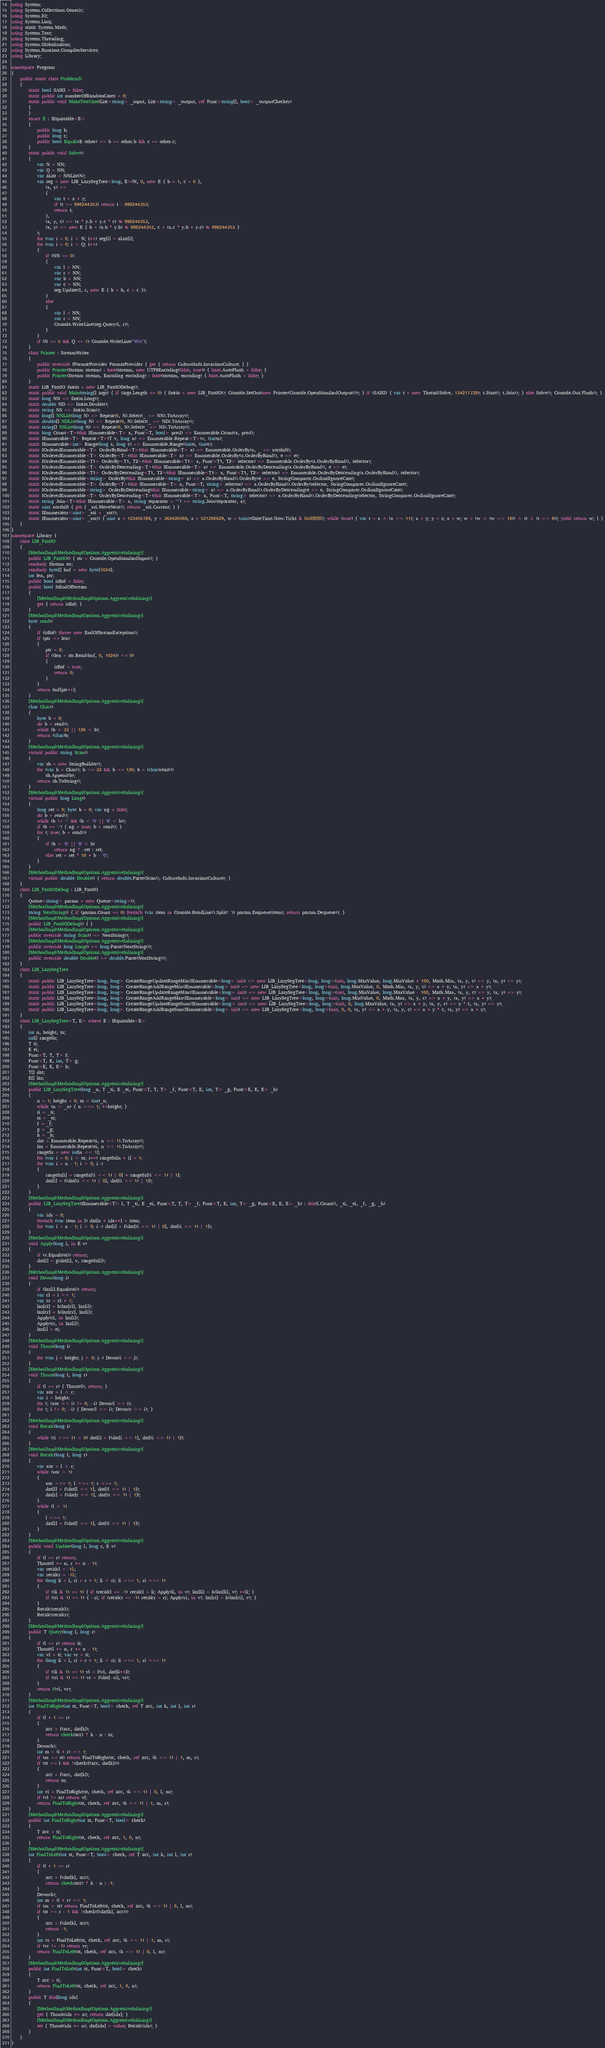Convert code to text. <code><loc_0><loc_0><loc_500><loc_500><_C#_>using System;
using System.Collections.Generic;
using System.IO;
using System.Linq;
using static System.Math;
using System.Text;
using System.Threading;
using System.Globalization;
using System.Runtime.CompilerServices;
using Library;

namespace Program
{
    public static class ProblemD
    {
        static bool SAIKI = false;
        static public int numberOfRandomCases = 0;
        static public void MakeTestCase(List<string> _input, List<string> _output, ref Func<string[], bool> _outputChecker)
        {
        }
        struct E : IEquatable<E>
        {
            public long b;
            public long c;
            public bool Equals(E other) => b == other.b && c == other.c;
        }
        static public void Solve()
        {
            var N = NN;
            var Q = NN;
            var aList = NNList(N);
            var seg = new LIB_LazySegTree<long, E>(N, 0, new E { b = 1, c = 0 },
                (x, y) =>
                {
                    var t = x + y;
                    if (t >= 998244353) return t - 998244353;
                    return t;
                },
                (x, y, c) => (x * y.b + y.c * c) % 998244353,
                (x, y) => new E { b = (x.b * y.b) % 998244353, c = (x.c * y.b + y.c) % 998244353 }
            );
            for (var i = 0; i < N; i++) seg[i] = aList[i];
            for (var i = 0; i < Q; i++)
            {
                if (NN == 0)
                {
                    var l = NN;
                    var r = NN;
                    var b = NN;
                    var c = NN;
                    seg.Update(l, r, new E { b = b, c = c });
                }
                else
                {
                    var l = NN;
                    var r = NN;
                    Console.WriteLine(seg.Query(l, r));
                }
            }
            if (N == 5 && Q == 7) Console.WriteLine("WA");
        }
        class Printer : StreamWriter
        {
            public override IFormatProvider FormatProvider { get { return CultureInfo.InvariantCulture; } }
            public Printer(Stream stream) : base(stream, new UTF8Encoding(false, true)) { base.AutoFlush = false; }
            public Printer(Stream stream, Encoding encoding) : base(stream, encoding) { base.AutoFlush = false; }
        }
        static LIB_FastIO fastio = new LIB_FastIODebug();
        static public void Main(string[] args) { if (args.Length == 0) { fastio = new LIB_FastIO(); Console.SetOut(new Printer(Console.OpenStandardOutput())); } if (SAIKI) { var t = new Thread(Solve, 134217728); t.Start(); t.Join(); } else Solve(); Console.Out.Flush(); }
        static long NN => fastio.Long();
        static double ND => fastio.Double();
        static string NS => fastio.Scan();
        static long[] NNList(long N) => Repeat(0, N).Select(_ => NN).ToArray();
        static double[] NDList(long N) => Repeat(0, N).Select(_ => ND).ToArray();
        static string[] NSList(long N) => Repeat(0, N).Select(_ => NS).ToArray();
        static long Count<T>(this IEnumerable<T> x, Func<T, bool> pred) => Enumerable.Count(x, pred);
        static IEnumerable<T> Repeat<T>(T v, long n) => Enumerable.Repeat<T>(v, (int)n);
        static IEnumerable<int> Range(long s, long c) => Enumerable.Range((int)s, (int)c);
        static IOrderedEnumerable<T> OrderByRand<T>(this IEnumerable<T> x) => Enumerable.OrderBy(x, _ => xorshift);
        static IOrderedEnumerable<T> OrderBy<T>(this IEnumerable<T> x) => Enumerable.OrderBy(x.OrderByRand(), e => e);
        static IOrderedEnumerable<T1> OrderBy<T1, T2>(this IEnumerable<T1> x, Func<T1, T2> selector) => Enumerable.OrderBy(x.OrderByRand(), selector);
        static IOrderedEnumerable<T> OrderByDescending<T>(this IEnumerable<T> x) => Enumerable.OrderByDescending(x.OrderByRand(), e => e);
        static IOrderedEnumerable<T1> OrderByDescending<T1, T2>(this IEnumerable<T1> x, Func<T1, T2> selector) => Enumerable.OrderByDescending(x.OrderByRand(), selector);
        static IOrderedEnumerable<string> OrderBy(this IEnumerable<string> x) => x.OrderByRand().OrderBy(e => e, StringComparer.OrdinalIgnoreCase);
        static IOrderedEnumerable<T> OrderBy<T>(this IEnumerable<T> x, Func<T, string> selector) => x.OrderByRand().OrderBy(selector, StringComparer.OrdinalIgnoreCase);
        static IOrderedEnumerable<string> OrderByDescending(this IEnumerable<string> x) => x.OrderByRand().OrderByDescending(e => e, StringComparer.OrdinalIgnoreCase);
        static IOrderedEnumerable<T> OrderByDescending<T>(this IEnumerable<T> x, Func<T, string> selector) => x.OrderByRand().OrderByDescending(selector, StringComparer.OrdinalIgnoreCase);
        static string Join<T>(this IEnumerable<T> x, string separator = "") => string.Join(separator, x);
        static uint xorshift { get { _xsi.MoveNext(); return _xsi.Current; } }
        static IEnumerator<uint> _xsi = _xsc();
        static IEnumerator<uint> _xsc() { uint x = 123456789, y = 362436069, z = 521288629, w = (uint)(DateTime.Now.Ticks & 0xffffffff); while (true) { var t = x ^ (x << 11); x = y; y = z; z = w; w = (w ^ (w >> 19)) ^ (t ^ (t >> 8)); yield return w; } }
    }
}
namespace Library {
    class LIB_FastIO
    {
        [MethodImpl(MethodImplOptions.AggressiveInlining)]
        public LIB_FastIO() { str = Console.OpenStandardInput(); }
        readonly Stream str;
        readonly byte[] buf = new byte[1024];
        int len, ptr;
        public bool isEof = false;
        public bool IsEndOfStream
        {
            [MethodImpl(MethodImplOptions.AggressiveInlining)]
            get { return isEof; }
        }
        [MethodImpl(MethodImplOptions.AggressiveInlining)]
        byte read()
        {
            if (isEof) throw new EndOfStreamException();
            if (ptr >= len)
            {
                ptr = 0;
                if ((len = str.Read(buf, 0, 1024)) <= 0)
                {
                    isEof = true;
                    return 0;
                }
            }
            return buf[ptr++];
        }
        [MethodImpl(MethodImplOptions.AggressiveInlining)]
        char Char()
        {
            byte b = 0;
            do b = read();
            while (b < 33 || 126 < b);
            return (char)b;
        }
        [MethodImpl(MethodImplOptions.AggressiveInlining)]
        virtual public string Scan()
        {
            var sb = new StringBuilder();
            for (var b = Char(); b >= 33 && b <= 126; b = (char)read())
                sb.Append(b);
            return sb.ToString();
        }
        [MethodImpl(MethodImplOptions.AggressiveInlining)]
        virtual public long Long()
        {
            long ret = 0; byte b = 0; var ng = false;
            do b = read();
            while (b != '-' && (b < '0' || '9' < b));
            if (b == '-') { ng = true; b = read(); }
            for (; true; b = read())
            {
                if (b < '0' || '9' < b)
                    return ng ? -ret : ret;
                else ret = ret * 10 + b - '0';
            }
        }
        [MethodImpl(MethodImplOptions.AggressiveInlining)]
        virtual public double Double() { return double.Parse(Scan(), CultureInfo.InvariantCulture); }
    }
    class LIB_FastIODebug : LIB_FastIO
    {
        Queue<string> param = new Queue<string>();
        [MethodImpl(MethodImplOptions.AggressiveInlining)]
        string NextString() { if (param.Count == 0) foreach (var item in Console.ReadLine().Split(' ')) param.Enqueue(item); return param.Dequeue(); }
        [MethodImpl(MethodImplOptions.AggressiveInlining)]
        public LIB_FastIODebug() { }
        [MethodImpl(MethodImplOptions.AggressiveInlining)]
        public override string Scan() => NextString();
        [MethodImpl(MethodImplOptions.AggressiveInlining)]
        public override long Long() => long.Parse(NextString());
        [MethodImpl(MethodImplOptions.AggressiveInlining)]
        public override double Double() => double.Parse(NextString());
    }
    class LIB_LazySegTree
    {
        static public LIB_LazySegTree<long, long> CreateRangeUpdateRangeMin(IEnumerable<long> init) => new LIB_LazySegTree<long, long>(init, long.MaxValue, long.MinValue + 100, Math.Min, (x, y, c) => y, (x, y) => y);
        static public LIB_LazySegTree<long, long> CreateRangeAddRangeMin(IEnumerable<long> init) => new LIB_LazySegTree<long, long>(init, long.MaxValue, 0, Math.Min, (x, y, c) => x + y, (x, y) => x + y);
        static public LIB_LazySegTree<long, long> CreateRangeUpdateRangeMax(IEnumerable<long> init) => new LIB_LazySegTree<long, long>(init, long.MinValue, long.MaxValue - 100, Math.Max, (x, y, c) => y, (x, y) => y);
        static public LIB_LazySegTree<long, long> CreateRangeAddRangeMax(IEnumerable<long> init) => new LIB_LazySegTree<long, long>(init, long.MinValue, 0, Math.Max, (x, y, c) => x + y, (x, y) => x + y);
        static public LIB_LazySegTree<long, long> CreateRangeUpdateRangeSum(IEnumerable<long> init) => new LIB_LazySegTree<long, long>(init, 0, long.MaxValue, (x, y) => x + y, (x, y, c) => y * c, (x, y) => y);
        static public LIB_LazySegTree<long, long> CreateRangeAddRangeSum(IEnumerable<long> init) => new LIB_LazySegTree<long, long>(init, 0, 0, (x, y) => x + y, (x, y, c) => x + y * c, (x, y) => x + y);
    }
    class LIB_LazySegTree<T, E> where E : IEquatable<E>
    {
        int n, height, sz;
        int[] rangeSz;
        T ti;
        E ei;
        Func<T, T, T> f;
        Func<T, E, int, T> g;
        Func<E, E, E> h;
        T[] dat;
        E[] laz;
        [MethodImpl(MethodImplOptions.AggressiveInlining)]
        public LIB_LazySegTree(long _n, T _ti, E _ei, Func<T, T, T> _f, Func<T, E, int, T> _g, Func<E, E, E> _h)
        {
            n = 1; height = 0; sz = (int)_n;
            while (n < _n) { n <<= 1; ++height; }
            ti = _ti;
            ei = _ei;
            f = _f;
            g = _g;
            h = _h;
            dat = Enumerable.Repeat(ti, n << 1).ToArray();
            laz = Enumerable.Repeat(ei, n << 1).ToArray();
            rangeSz = new int[n << 1];
            for (var i = 0; i < sz; i++) rangeSz[n + i] = 1;
            for (var i = n - 1; i > 0; i--)
            {
                rangeSz[i] = rangeSz[(i << 1) | 0] + rangeSz[(i << 1) | 1];
                dat[i] = f(dat[(i << 1) | 0], dat[(i << 1) | 1]);
            }
        }
        [MethodImpl(MethodImplOptions.AggressiveInlining)]
        public LIB_LazySegTree(IEnumerable<T> l, T _ti, E _ei, Func<T, T, T> _f, Func<T, E, int, T> _g, Func<E, E, E> _h) : this(l.Count(), _ti, _ei, _f, _g, _h)
        {
            var idx = 0;
            foreach (var item in l) dat[n + idx++] = item;
            for (var i = n - 1; i > 0; i--) dat[i] = f(dat[(i << 1) | 0], dat[(i << 1) | 1]);
        }
        [MethodImpl(MethodImplOptions.AggressiveInlining)]
        void Apply(long i, in E v)
        {
            if (v.Equals(ei)) return;
            dat[i] = g(dat[i], v, rangeSz[i]);
        }
        [MethodImpl(MethodImplOptions.AggressiveInlining)]
        void Down(long i)
        {
            if (laz[i].Equals(ei)) return;
            var cl = i << 1;
            var cr = cl + 1;
            laz[cl] = h(laz[cl], laz[i]);
            laz[cr] = h(laz[cr], laz[i]);
            Apply(cl, in laz[i]);
            Apply(cr, in laz[i]);
            laz[i] = ei;
        }
        [MethodImpl(MethodImplOptions.AggressiveInlining)]
        void Thrust(long i)
        {
            for (var j = height; j > 0; j--) Down(i >> j);
        }
        [MethodImpl(MethodImplOptions.AggressiveInlining)]
        void Thrust(long l, long r)
        {
            if (l == r) { Thrust(l); return; }
            var xor = l ^ r;
            var i = height;
            for (; (xor >> i) != 0; --i) Down(l >> i);
            for (; i != 0; --i) { Down(l >> i); Down(r >> i); }
        }
        [MethodImpl(MethodImplOptions.AggressiveInlining)]
        void Recalc(long i)
        {
            while ((i >>= 1) > 0) dat[i] = f(dat[i << 1], dat[(i << 1) | 1]);
        }
        [MethodImpl(MethodImplOptions.AggressiveInlining)]
        void Recalc(long l, long r)
        {
            var xor = l ^ r;
            while (xor > 1)
            {
                xor >>= 1; l >>= 1; r >>= 1;
                dat[l] = f(dat[l << 1], dat[(l << 1) | 1]);
                dat[r] = f(dat[r << 1], dat[(r << 1) | 1]);
            }
            while (l > 1)
            {
                l >>= 1;
                dat[l] = f(dat[l << 1], dat[(l << 1) | 1]);
            }
        }
        [MethodImpl(MethodImplOptions.AggressiveInlining)]
        public void Update(long l, long r, E v)
        {
            if (l == r) return;
            Thrust(l += n, r += n - 1);
            var recalcl = -1L;
            var recalcr = -1L;
            for (long li = l, ri = r + 1; li < ri; li >>= 1, ri >>= 1)
            {
                if ((li & 1) == 1) { if (recalcl == -1) recalcl = li; Apply(li, in v); laz[li] = h(laz[li], v); ++li; }
                if ((ri & 1) == 1) { --ri; if (recalcr == -1) recalcr = ri; Apply(ri, in v); laz[ri] = h(laz[ri], v); }
            }
            Recalc(recalcl);
            Recalc(recalcr);
        }
        [MethodImpl(MethodImplOptions.AggressiveInlining)]
        public T Query(long l, long r)
        {
            if (l == r) return ti;
            Thrust(l += n, r += n - 1);
            var vl = ti; var vr = ti;
            for (long li = l, ri = r + 1; li < ri; li >>= 1, ri >>= 1)
            {
                if ((li & 1) == 1) vl = f(vl, dat[li++]);
                if ((ri & 1) == 1) vr = f(dat[--ri], vr);
            }
            return f(vl, vr);
        }
        [MethodImpl(MethodImplOptions.AggressiveInlining)]
        int FindToRight(int st, Func<T, bool> check, ref T acc, int k, int l, int r)
        {
            if (l + 1 == r)
            {
                acc = f(acc, dat[k]);
                return check(acc) ? k - n : sz;
            }
            Down(k);
            int m = (l + r) >> 1;
            if (m <= st) return FindToRight(st, check, ref acc, (k << 1) | 1, m, r);
            if (st <= l && !check(f(acc, dat[k])))
            {
                acc = f(acc, dat[k]);
                return sz;
            }
            int vl = FindToRight(st, check, ref acc, (k << 1) | 0, l, m);
            if (vl != sz) return vl;
            return FindToRight(st, check, ref acc, (k << 1) | 1, m, r);
        }
        [MethodImpl(MethodImplOptions.AggressiveInlining)]
        public int FindToRight(int st, Func<T, bool> check)
        {
            T acc = ti;
            return FindToRight(st, check, ref acc, 1, 0, n);
        }
        [MethodImpl(MethodImplOptions.AggressiveInlining)]
        int FindToLeft(int st, Func<T, bool> check, ref T acc, int k, int l, int r)
        {
            if (l + 1 == r)
            {
                acc = f(dat[k], acc);
                return check(acc) ? k - n : -1;
            }
            Down(k);
            int m = (l + r) >> 1;
            if (m > st) return FindToLeft(st, check, ref acc, (k << 1) | 0, l, m);
            if (st >= r - 1 && !check(f(dat[k], acc)))
            {
                acc = f(dat[k], acc);
                return -1;
            }
            int vr = FindToLeft(st, check, ref acc, (k << 1) | 1, m, r);
            if (vr != -1) return vr;
            return FindToLeft(st, check, ref acc, (k << 1) | 0, l, m);
        }
        [MethodImpl(MethodImplOptions.AggressiveInlining)]
        public int FindToLeft(int st, Func<T, bool> check)
        {
            T acc = ti;
            return FindToLeft(st, check, ref acc, 1, 0, n);
        }
        public T this[long idx]
        {
            [MethodImpl(MethodImplOptions.AggressiveInlining)]
            get { Thrust(idx += n); return dat[idx]; }
            [MethodImpl(MethodImplOptions.AggressiveInlining)]
            set { Thrust(idx += n); dat[idx] = value; Recalc(idx); }
        }
    }
}
</code> 